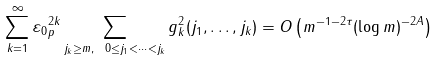Convert formula to latex. <formula><loc_0><loc_0><loc_500><loc_500>\sum _ { k = 1 } ^ { \infty } \| \varepsilon _ { 0 } \| _ { p } ^ { 2 k } \sum _ { j _ { k } \geq m , \ 0 \leq j _ { 1 } < \cdots < j _ { k } } g ^ { 2 } _ { k } ( j _ { 1 } , \dots , j _ { k } ) = O \left ( m ^ { - 1 - 2 \tau } ( \log m ) ^ { - 2 A } \right )</formula> 